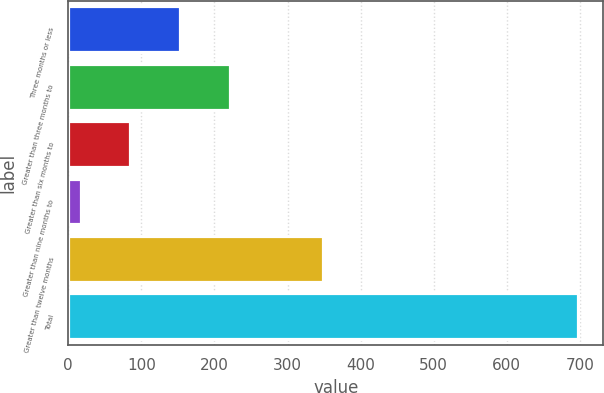<chart> <loc_0><loc_0><loc_500><loc_500><bar_chart><fcel>Three months or less<fcel>Greater than three months to<fcel>Greater than six months to<fcel>Greater than nine months to<fcel>Greater than twelve months<fcel>Total<nl><fcel>153<fcel>221<fcel>85<fcel>17<fcel>349<fcel>697<nl></chart> 